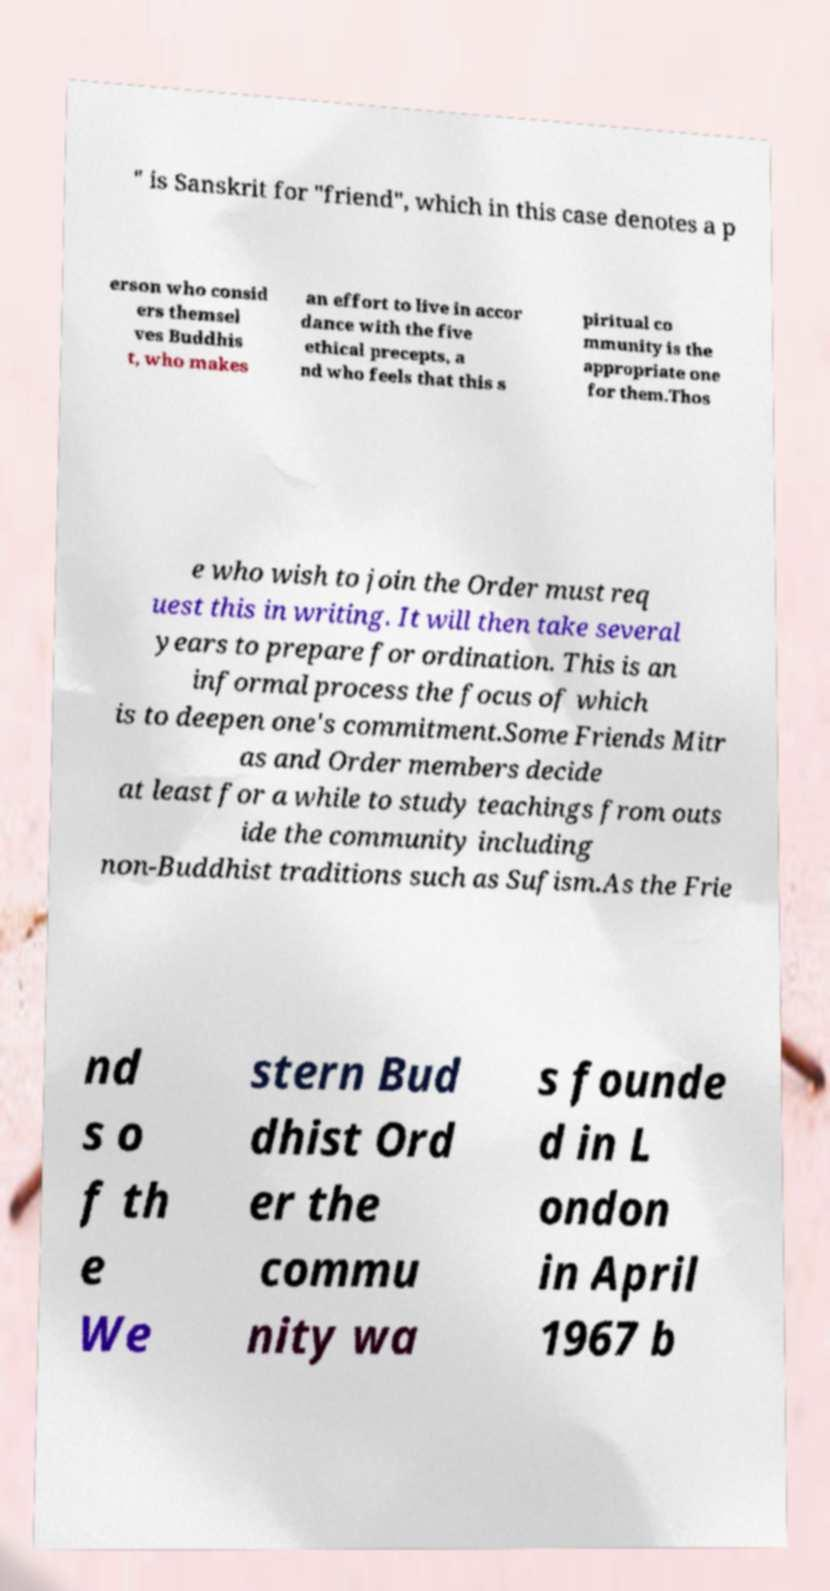Please identify and transcribe the text found in this image. " is Sanskrit for "friend", which in this case denotes a p erson who consid ers themsel ves Buddhis t, who makes an effort to live in accor dance with the five ethical precepts, a nd who feels that this s piritual co mmunity is the appropriate one for them.Thos e who wish to join the Order must req uest this in writing. It will then take several years to prepare for ordination. This is an informal process the focus of which is to deepen one's commitment.Some Friends Mitr as and Order members decide at least for a while to study teachings from outs ide the community including non-Buddhist traditions such as Sufism.As the Frie nd s o f th e We stern Bud dhist Ord er the commu nity wa s founde d in L ondon in April 1967 b 